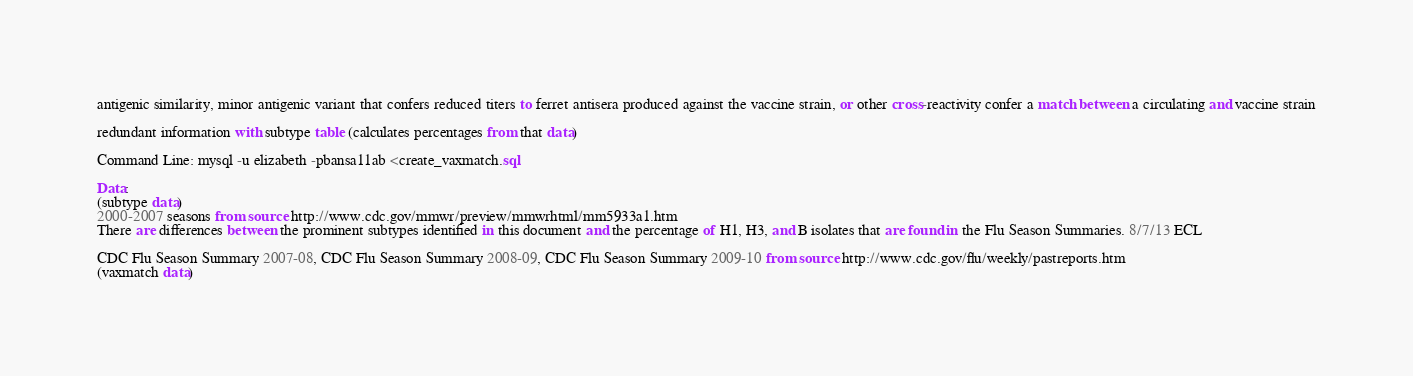<code> <loc_0><loc_0><loc_500><loc_500><_SQL_>
antigenic similarity, minor antigenic variant that confers reduced titers to ferret antisera produced against the vaccine strain, or other cross-reactivity confer a match between a circulating and vaccine strain

redundant information with subtype table (calculates percentages from that data)

Command Line: mysql -u elizabeth -pbansa11ab <create_vaxmatch.sql

Data: 
(subtype data)
2000-2007 seasons from source http://www.cdc.gov/mmwr/preview/mmwrhtml/mm5933a1.htm
There are differences between the prominent subtypes identified in this document and the percentage of H1, H3, and B isolates that are found in the Flu Season Summaries. 8/7/13 ECL

CDC Flu Season Summary 2007-08, CDC Flu Season Summary 2008-09, CDC Flu Season Summary 2009-10 from source http://www.cdc.gov/flu/weekly/pastreports.htm
(vaxmatch data)</code> 